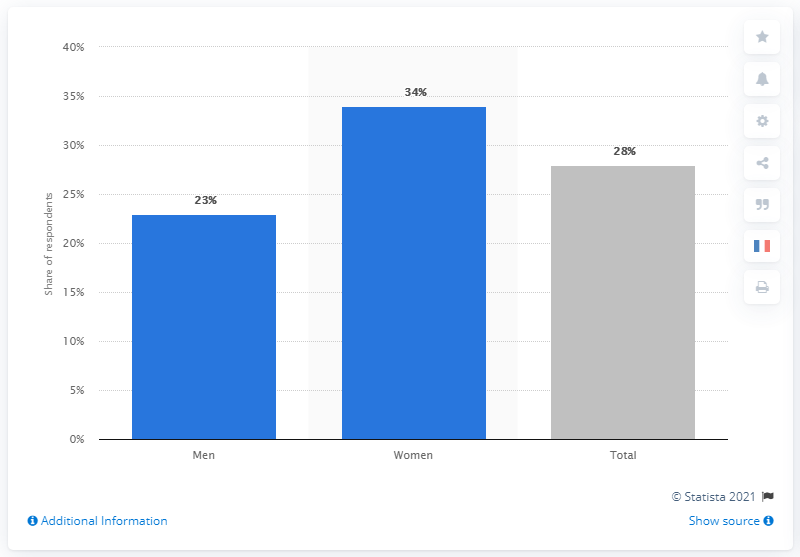What are the corresponding percentages for women and the total population worried about Coronavirus? The chart indicates that 34% of women and 28% of the total population surveyed were worried about Coronavirus. 